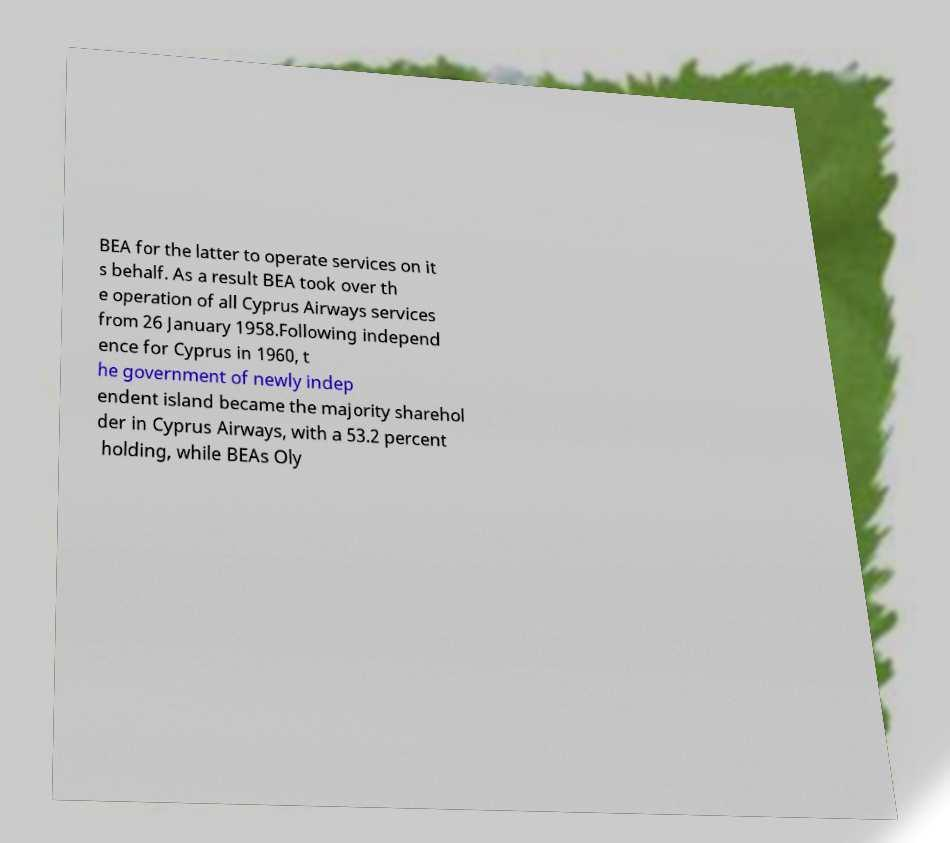Can you accurately transcribe the text from the provided image for me? BEA for the latter to operate services on it s behalf. As a result BEA took over th e operation of all Cyprus Airways services from 26 January 1958.Following independ ence for Cyprus in 1960, t he government of newly indep endent island became the majority sharehol der in Cyprus Airways, with a 53.2 percent holding, while BEAs Oly 